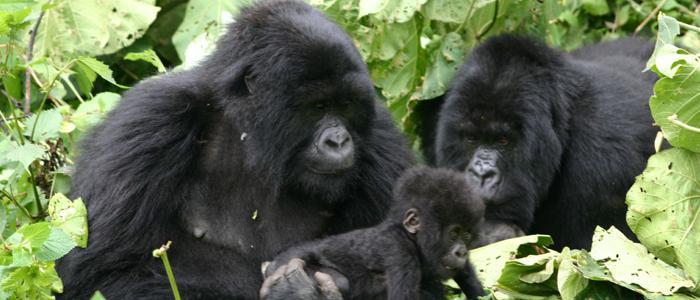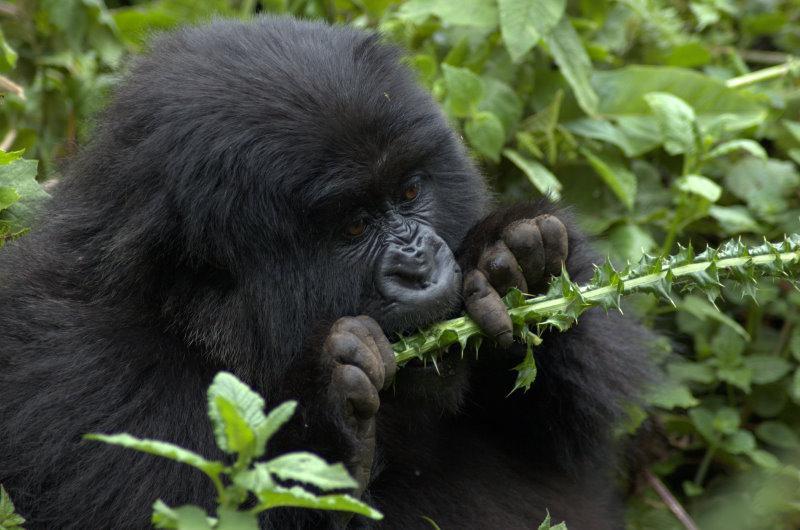The first image is the image on the left, the second image is the image on the right. Examine the images to the left and right. Is the description "Three gorillas sit in the grass in the image on the right." accurate? Answer yes or no. No. The first image is the image on the left, the second image is the image on the right. Considering the images on both sides, is "The right image includes no more than two apes." valid? Answer yes or no. Yes. 